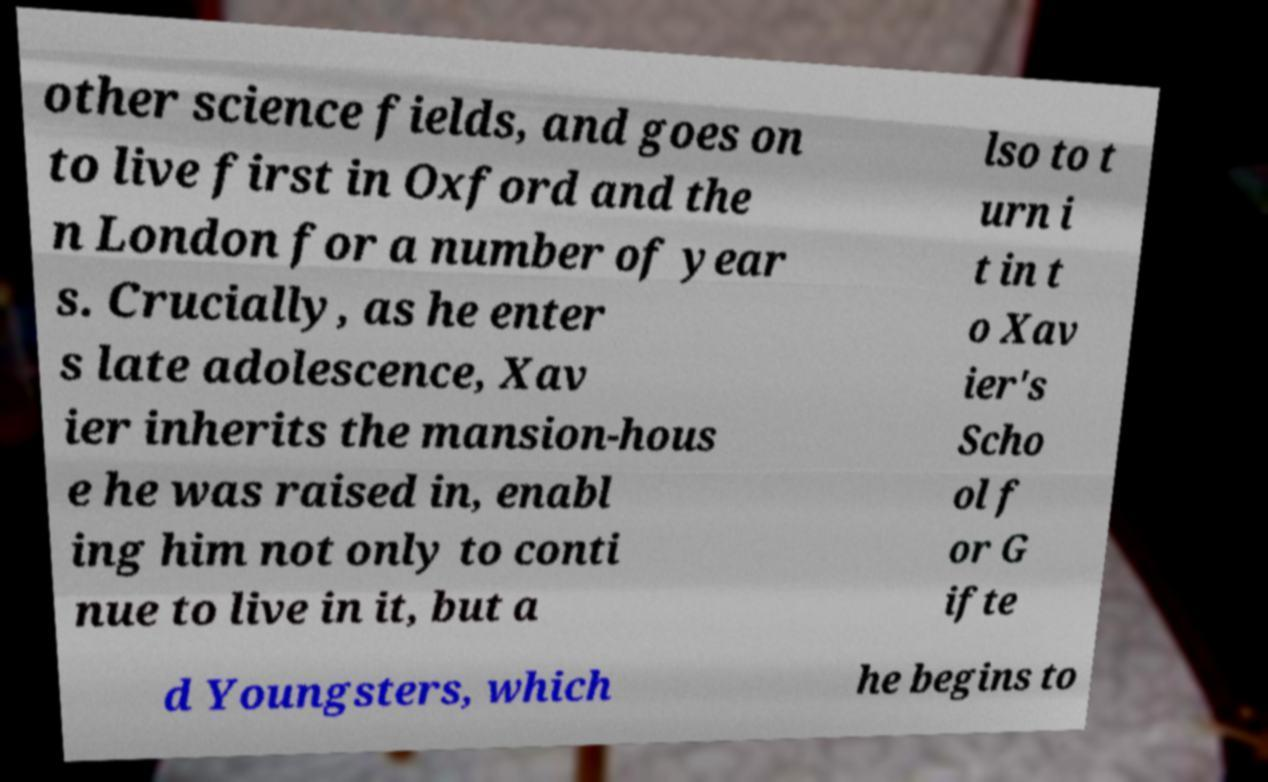Please identify and transcribe the text found in this image. other science fields, and goes on to live first in Oxford and the n London for a number of year s. Crucially, as he enter s late adolescence, Xav ier inherits the mansion-hous e he was raised in, enabl ing him not only to conti nue to live in it, but a lso to t urn i t in t o Xav ier's Scho ol f or G ifte d Youngsters, which he begins to 